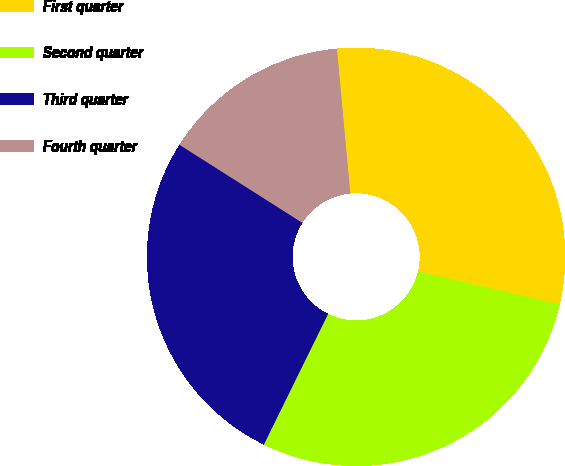Convert chart to OTSL. <chart><loc_0><loc_0><loc_500><loc_500><pie_chart><fcel>First quarter<fcel>Second quarter<fcel>Third quarter<fcel>Fourth quarter<nl><fcel>30.12%<fcel>28.62%<fcel>26.73%<fcel>14.53%<nl></chart> 